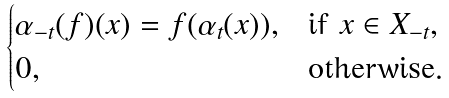Convert formula to latex. <formula><loc_0><loc_0><loc_500><loc_500>\begin{cases} \alpha _ { - t } ( f ) ( x ) = f ( \alpha _ { t } ( x ) ) , & \text {if } x \in X _ { - t } , \\ 0 , & \text {otherwise} . \end{cases}</formula> 